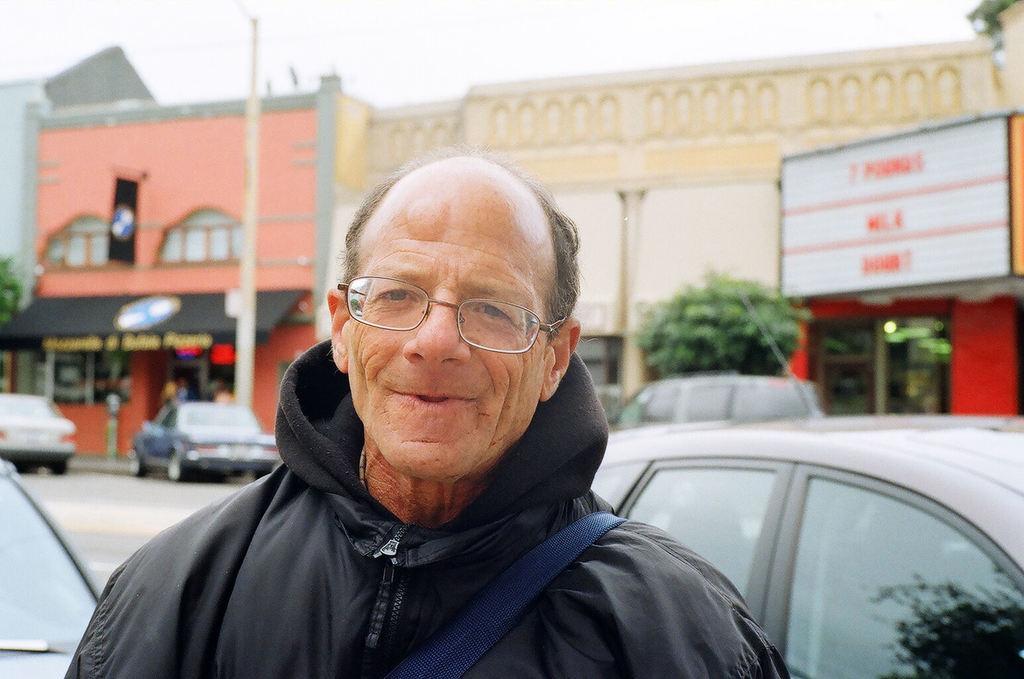Describe this image in one or two sentences. In the image there is a man, he is smiling and he is also wearing spectacles. Behind the man there are few cars and buildings, in the background there is a sky. 